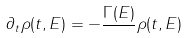<formula> <loc_0><loc_0><loc_500><loc_500>\partial _ { t } \rho ( t , E ) = - \frac { \Gamma ( E ) } { } \rho ( t , E )</formula> 